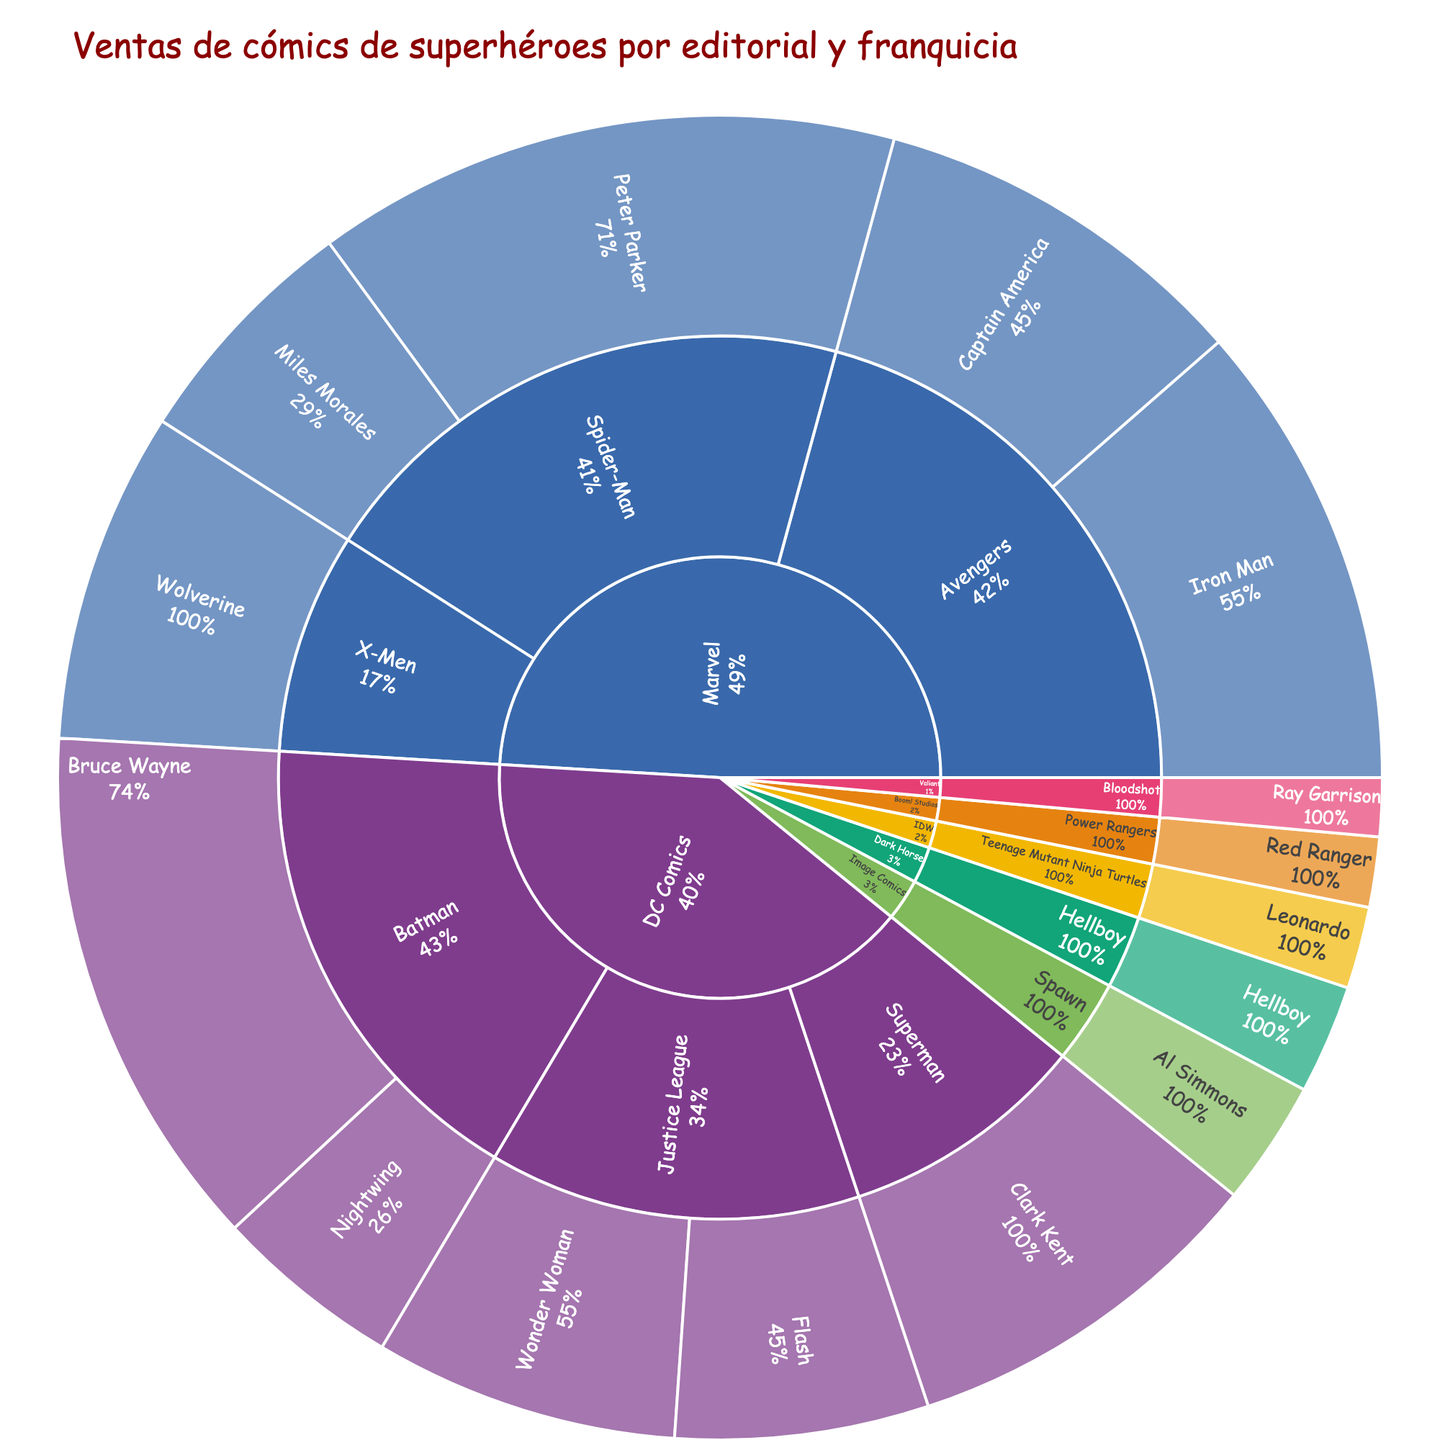What's the title of the sunburst plot? The title is usually displayed at the top of the plot. In this case, it clearly states the topic of the plot.
Answer: Ventas de cómics de superhéroes por editorial y franquicia Which character has the highest comic book sales? To answer this, look for the largest segment at the deepest level of the chart which displays the characters.
Answer: Peter Parker How do the total sales of Marvel comics compare to those of DC Comics? Compare the size of the outer segments labeled 'Marvel' and 'DC Comics' to see which is larger.
Answer: Marvel has higher total sales Which franchise within Marvel has the highest sales? Focus on the segment labeled 'Marvel' and identify the largest franchise segment within it.
Answer: Spider-Man What percentage of Marvel’s total sales come from the Spider-Man franchise? Calculate the proportion of Spider-Man's sales relative to the total sales for Marvel by looking at the size of the Spider-Man segment within Marvel.
Answer: 45.2% What is the combined sales total of all Batman-related comics from DC Comics? Sum the sales values for Bruce Wayne and Nightwing under the Batman franchise.
Answer: 1,830,000 How do the sales of Iron Man compare to those of Clark Kent? Identify the sales values for Iron Man and Clark Kent and compare them directly.
Answer: Iron Man's sales are higher Among the listed publishers, which one has the least total sales? Identify the smallest parent segment in the outer ring representing each publisher.
Answer: Valiant Which character franchise has the most characters listed in the data? Look at the number of character nodes under each franchise node to determine which has the most.
Answer: Batman What percentage of total sales does DC Comics contribute? Compare the size of the DC Comics segment to the total size of all segments to estimate the percentage.
Answer: Approximately 45% 